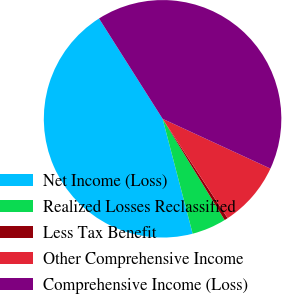Convert chart to OTSL. <chart><loc_0><loc_0><loc_500><loc_500><pie_chart><fcel>Net Income (Loss)<fcel>Realized Losses Reclassified<fcel>Less Tax Benefit<fcel>Other Comprehensive Income<fcel>Comprehensive Income (Loss)<nl><fcel>45.08%<fcel>4.68%<fcel>0.47%<fcel>8.89%<fcel>40.87%<nl></chart> 